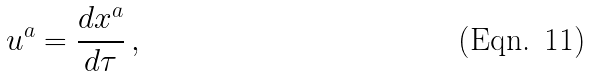<formula> <loc_0><loc_0><loc_500><loc_500>u ^ { a } = \frac { d x ^ { a } } { d \tau } \, ,</formula> 